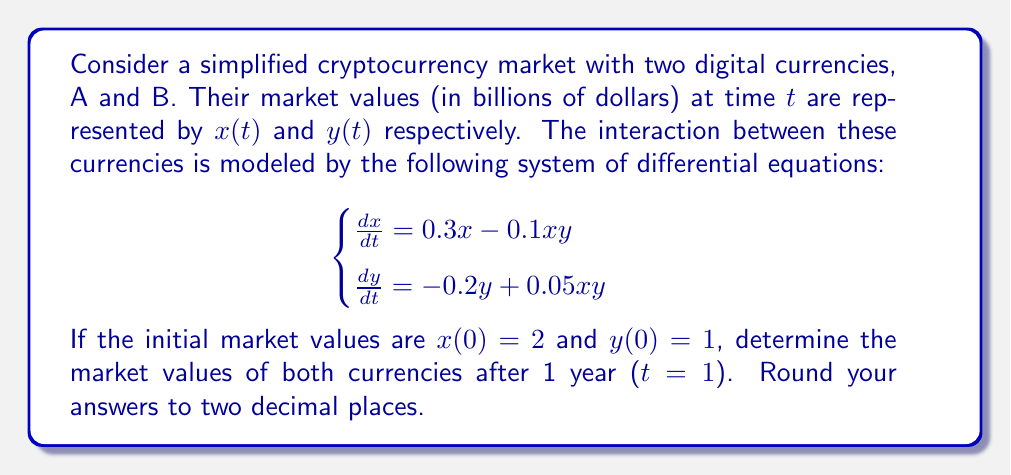What is the answer to this math problem? To solve this system of differential equations, we'll use numerical methods, specifically the fourth-order Runge-Kutta method (RK4). This method is suitable for our persona as it's commonly used in financial modeling.

Step 1: Define the functions for dx/dt and dy/dt
$$f(x,y) = 0.3x - 0.1xy$$
$$g(x,y) = -0.2y + 0.05xy$$

Step 2: Set up the RK4 method
For a step size h, the RK4 method is given by:

$$\begin{align*}
k_1 &= hf(x_n, y_n) \\
l_1 &= hg(x_n, y_n) \\
k_2 &= hf(x_n + \frac{k_1}{2}, y_n + \frac{l_1}{2}) \\
l_2 &= hg(x_n + \frac{k_1}{2}, y_n + \frac{l_1}{2}) \\
k_3 &= hf(x_n + \frac{k_2}{2}, y_n + \frac{l_2}{2}) \\
l_3 &= hg(x_n + \frac{k_2}{2}, y_n + \frac{l_2}{2}) \\
k_4 &= hf(x_n + k_3, y_n + l_3) \\
l_4 &= hg(x_n + k_3, y_n + l_3)
\end{align*}$$

$$\begin{align*}
x_{n+1} &= x_n + \frac{1}{6}(k_1 + 2k_2 + 2k_3 + k_4) \\
y_{n+1} &= y_n + \frac{1}{6}(l_1 + 2l_2 + 2l_3 + l_4)
\end{align*}$$

Step 3: Implement the RK4 method
Let's use a step size of h = 0.1, which means we'll calculate 10 steps to reach t = 1.

Initial values: $x_0 = 2$, $y_0 = 1$

Calculating the first step (n = 0):
$$\begin{align*}
k_1 &= 0.1(0.3 \cdot 2 - 0.1 \cdot 2 \cdot 1) = 0.05 \\
l_1 &= 0.1(-0.2 \cdot 1 + 0.05 \cdot 2 \cdot 1) = -0.01 \\
k_2 &= 0.1(0.3 \cdot 2.025 - 0.1 \cdot 2.025 \cdot 0.995) = 0.0506 \\
l_2 &= 0.1(-0.2 \cdot 0.995 + 0.05 \cdot 2.025 \cdot 0.995) = -0.0099 \\
k_3 &= 0.1(0.3 \cdot 2.0253 - 0.1 \cdot 2.0253 \cdot 0.9951) = 0.0507 \\
l_3 &= 0.1(-0.2 \cdot 0.9951 + 0.05 \cdot 2.0253 \cdot 0.9951) = -0.0099 \\
k_4 &= 0.1(0.3 \cdot 2.0507 - 0.1 \cdot 2.0507 \cdot 0.9901) = 0.0513 \\
l_4 &= 0.1(-0.2 \cdot 0.9901 + 0.05 \cdot 2.0507 \cdot 0.9901) = -0.0098
\end{align*}$$

$$\begin{align*}
x_1 &= 2 + \frac{1}{6}(0.05 + 2 \cdot 0.0506 + 2 \cdot 0.0507 + 0.0513) = 2.0507 \\
y_1 &= 1 + \frac{1}{6}(-0.01 + 2 \cdot (-0.0099) + 2 \cdot (-0.0099) + (-0.0098)) = 0.9901
\end{align*}$$

Step 4: Repeat the process
We continue this process for the remaining 9 steps. After 10 steps, we reach t = 1 with the following values:

$x(1) \approx 2.71$
$y(1) \approx 0.91$
Answer: $x(1) \approx 2.71$, $y(1) \approx 0.91$ 